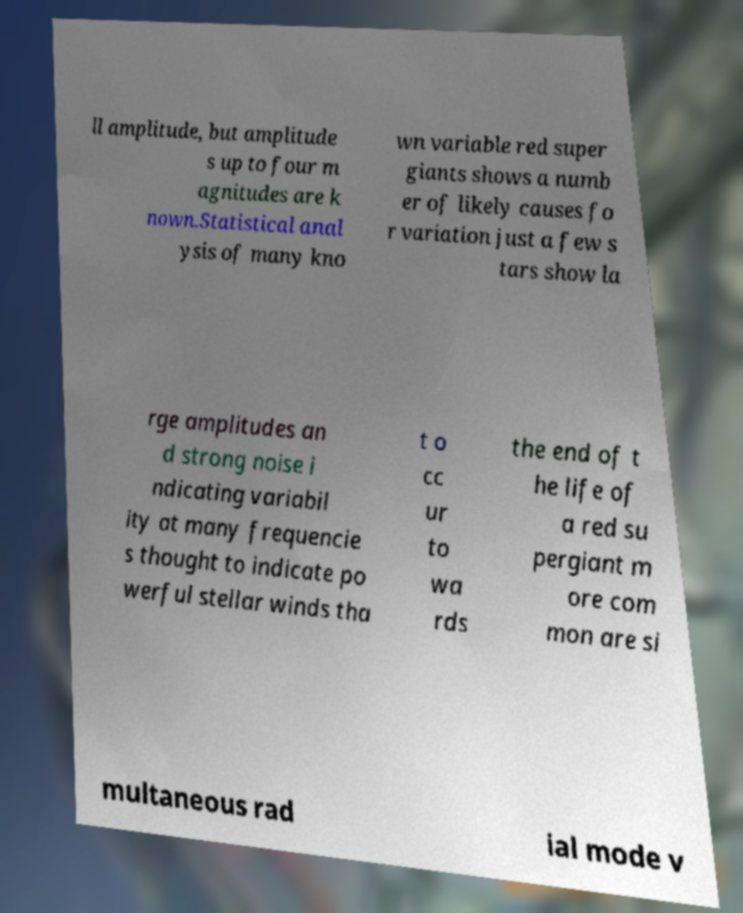Can you read and provide the text displayed in the image?This photo seems to have some interesting text. Can you extract and type it out for me? ll amplitude, but amplitude s up to four m agnitudes are k nown.Statistical anal ysis of many kno wn variable red super giants shows a numb er of likely causes fo r variation just a few s tars show la rge amplitudes an d strong noise i ndicating variabil ity at many frequencie s thought to indicate po werful stellar winds tha t o cc ur to wa rds the end of t he life of a red su pergiant m ore com mon are si multaneous rad ial mode v 